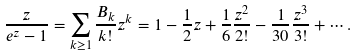Convert formula to latex. <formula><loc_0><loc_0><loc_500><loc_500>\frac { z } { e ^ { z } - 1 } = \sum _ { k \geq 1 } \frac { B _ { k } } { k ! } z ^ { k } = 1 - \frac { 1 } { 2 } z + \frac { 1 } { 6 } \frac { z ^ { 2 } } { 2 ! } - \frac { 1 } { 3 0 } \frac { z ^ { 3 } } { 3 ! } + \cdots .</formula> 